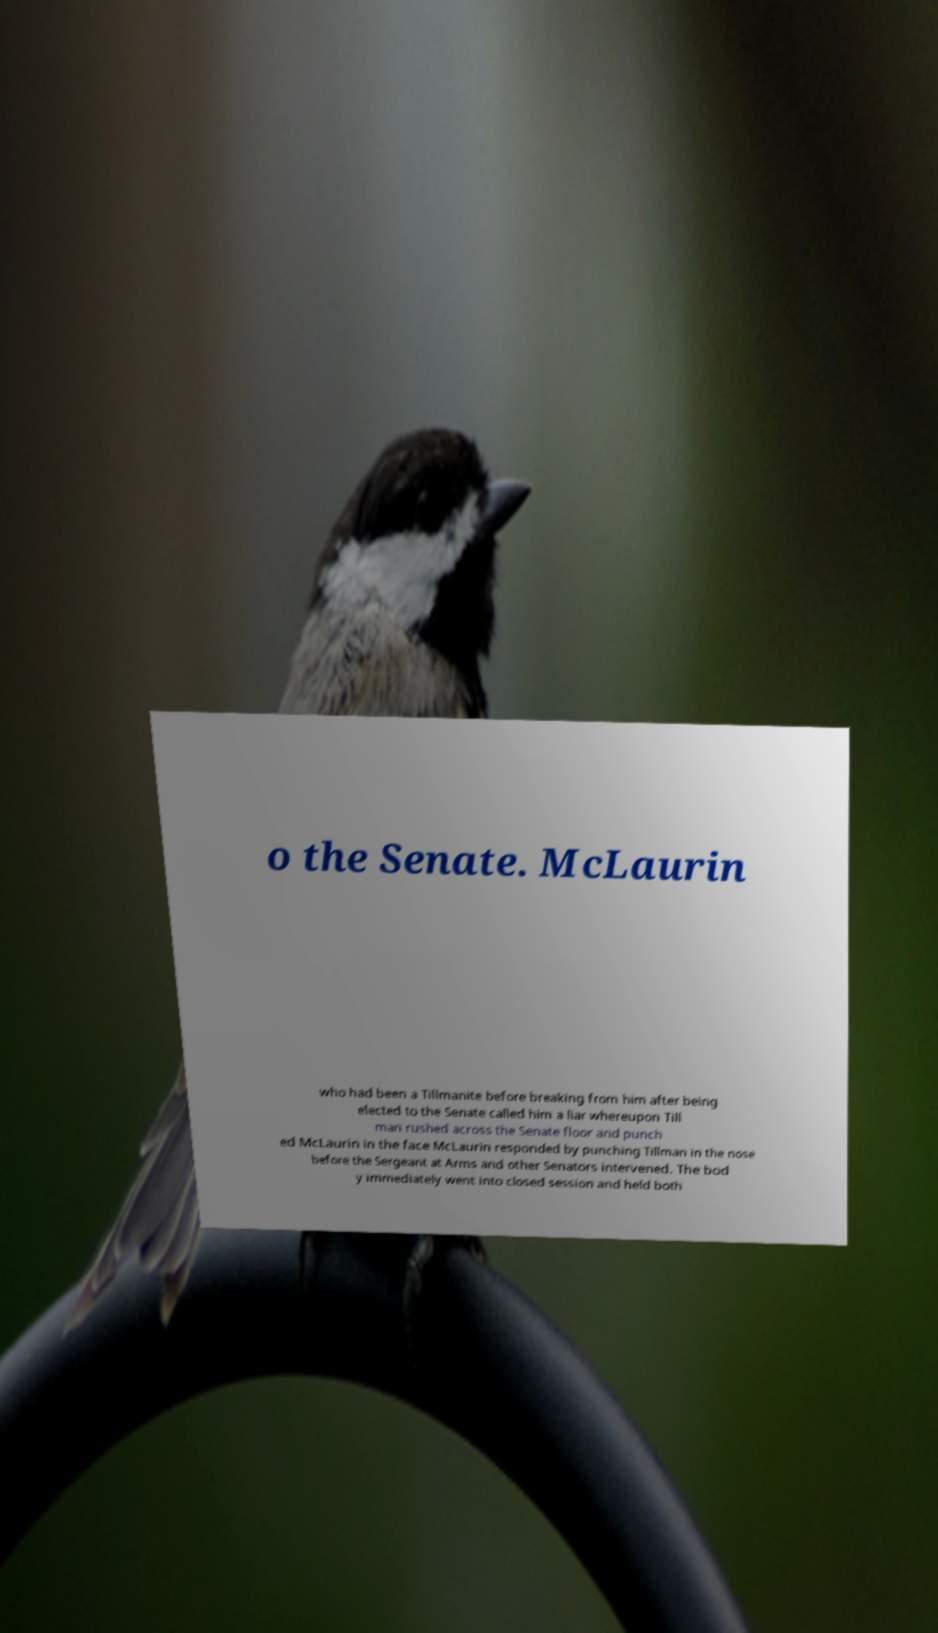I need the written content from this picture converted into text. Can you do that? o the Senate. McLaurin who had been a Tillmanite before breaking from him after being elected to the Senate called him a liar whereupon Till man rushed across the Senate floor and punch ed McLaurin in the face McLaurin responded by punching Tillman in the nose before the Sergeant at Arms and other Senators intervened. The bod y immediately went into closed session and held both 